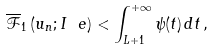<formula> <loc_0><loc_0><loc_500><loc_500>\overline { \mathcal { F } } _ { 1 } \left ( u _ { n } ; I _ { \ } e \right ) < \int _ { L + 1 } ^ { + \infty } \psi ( t ) \, d t \, ,</formula> 